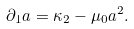<formula> <loc_0><loc_0><loc_500><loc_500>\partial _ { 1 } a = \kappa _ { 2 } - \mu _ { 0 } a ^ { 2 } .</formula> 